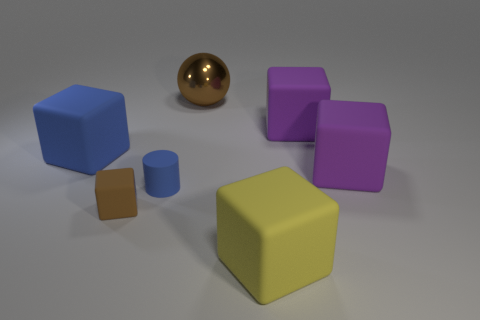Does the metallic thing have the same size as the brown cube?
Provide a short and direct response. No. There is a brown thing that is right of the brown rubber thing; what is its material?
Keep it short and to the point. Metal. How many other objects are there of the same shape as the large yellow object?
Provide a succinct answer. 4. Is the shape of the large blue matte thing the same as the tiny brown thing?
Provide a short and direct response. Yes. There is a small brown block; are there any large blocks in front of it?
Keep it short and to the point. Yes. How many objects are either green blocks or metallic objects?
Keep it short and to the point. 1. What number of other things are there of the same size as the yellow block?
Keep it short and to the point. 4. How many objects are to the right of the blue block and behind the matte cylinder?
Offer a terse response. 3. There is a rubber cube in front of the brown rubber block; is it the same size as the blue matte thing right of the blue cube?
Offer a very short reply. No. What is the size of the purple rubber object that is behind the big blue rubber object?
Provide a succinct answer. Large. 